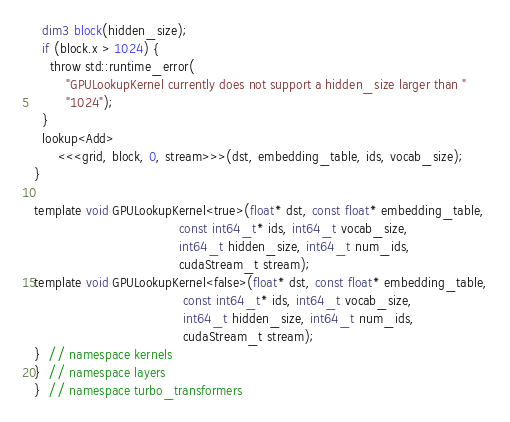<code> <loc_0><loc_0><loc_500><loc_500><_Cuda_>  dim3 block(hidden_size);
  if (block.x > 1024) {
    throw std::runtime_error(
        "GPULookupKernel currently does not support a hidden_size larger than "
        "1024");
  }
  lookup<Add>
      <<<grid, block, 0, stream>>>(dst, embedding_table, ids, vocab_size);
}

template void GPULookupKernel<true>(float* dst, const float* embedding_table,
                                    const int64_t* ids, int64_t vocab_size,
                                    int64_t hidden_size, int64_t num_ids,
                                    cudaStream_t stream);
template void GPULookupKernel<false>(float* dst, const float* embedding_table,
                                     const int64_t* ids, int64_t vocab_size,
                                     int64_t hidden_size, int64_t num_ids,
                                     cudaStream_t stream);
}  // namespace kernels
}  // namespace layers
}  // namespace turbo_transformers
</code> 